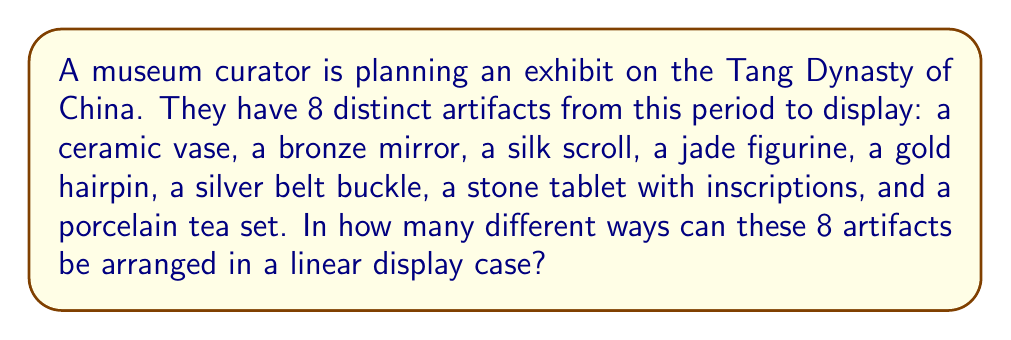Solve this math problem. Let's approach this step-by-step:

1) This is a permutation problem. We need to find the number of ways to arrange 8 distinct objects in a line.

2) In permutation problems, the order matters. Each unique arrangement is considered a different permutation.

3) For the first position, we have 8 choices of artifacts.

4) After placing the first artifact, we have 7 choices for the second position.

5) For the third position, we have 6 choices, and so on.

6) This continues until we place the last artifact, for which we have only 1 choice.

7) The total number of permutations is the product of all these choices:

   $$ 8 \times 7 \times 6 \times 5 \times 4 \times 3 \times 2 \times 1 $$

8) This product is known as 8 factorial, denoted as 8!

9) Therefore, the number of ways to arrange the artifacts is:

   $$ 8! = 40,320 $$
Answer: 40,320 